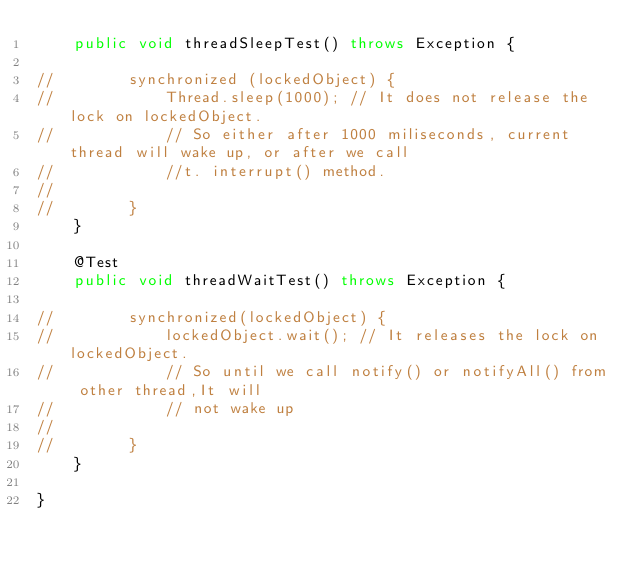Convert code to text. <code><loc_0><loc_0><loc_500><loc_500><_Java_>    public void threadSleepTest() throws Exception {

//        synchronized (lockedObject) {
//            Thread.sleep(1000); // It does not release the lock on lockedObject.
//            // So either after 1000 miliseconds, current thread will wake up, or after we call
//            //t. interrupt() method.
//
//        }
    }

    @Test
    public void threadWaitTest() throws Exception {

//        synchronized(lockedObject) {
//            lockedObject.wait(); // It releases the lock on lockedObject.
//            // So until we call notify() or notifyAll() from other thread,It will
//            // not wake up
//
//        }
    }

}
</code> 